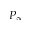<formula> <loc_0><loc_0><loc_500><loc_500>P _ { \infty }</formula> 